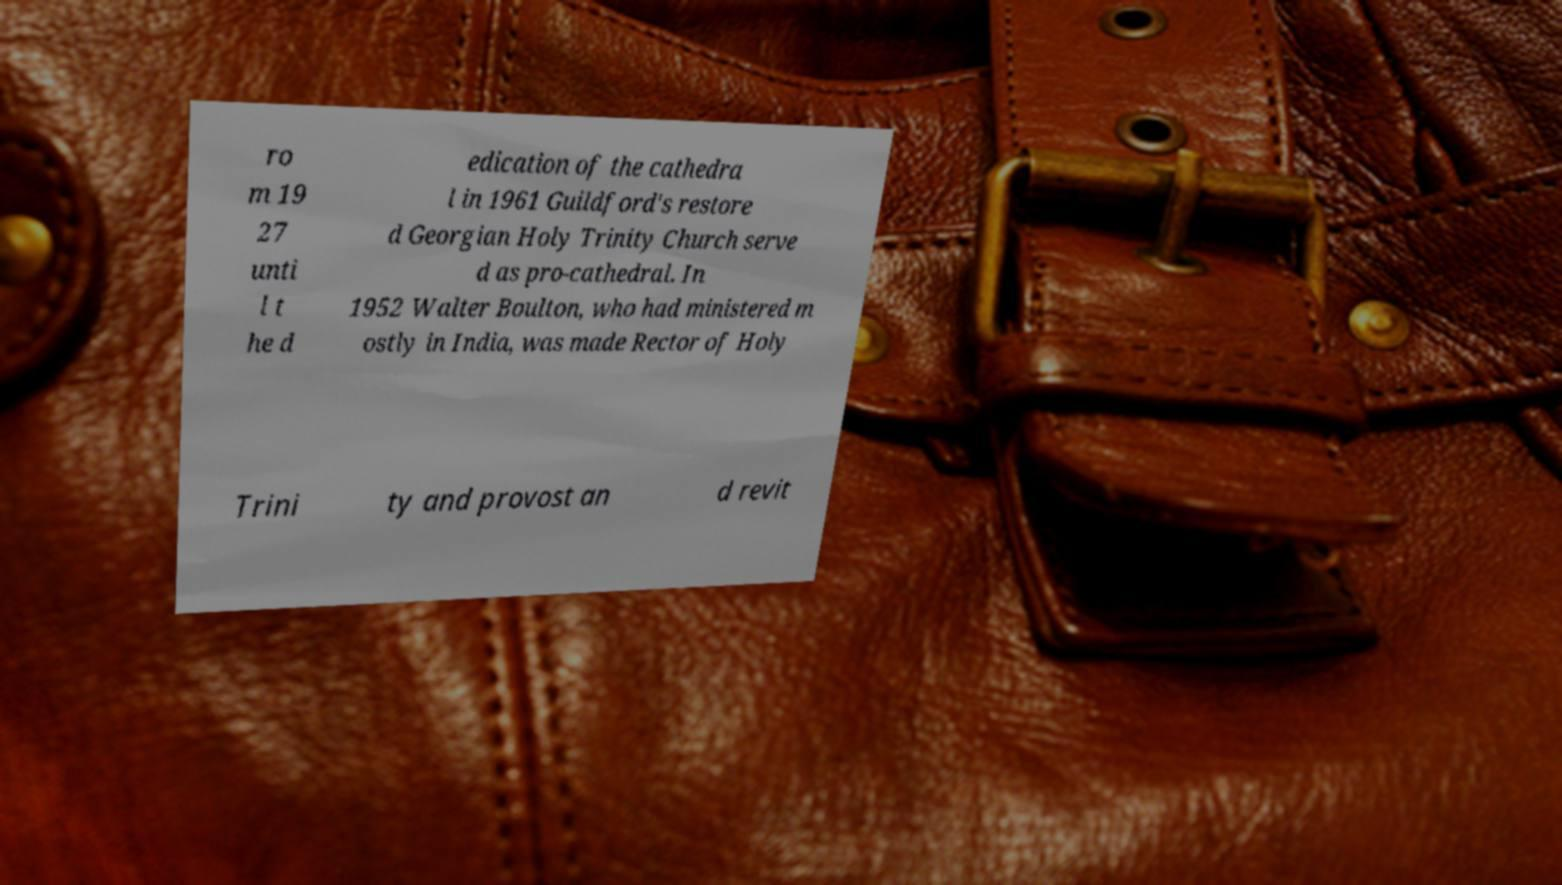Could you assist in decoding the text presented in this image and type it out clearly? ro m 19 27 unti l t he d edication of the cathedra l in 1961 Guildford's restore d Georgian Holy Trinity Church serve d as pro-cathedral. In 1952 Walter Boulton, who had ministered m ostly in India, was made Rector of Holy Trini ty and provost an d revit 